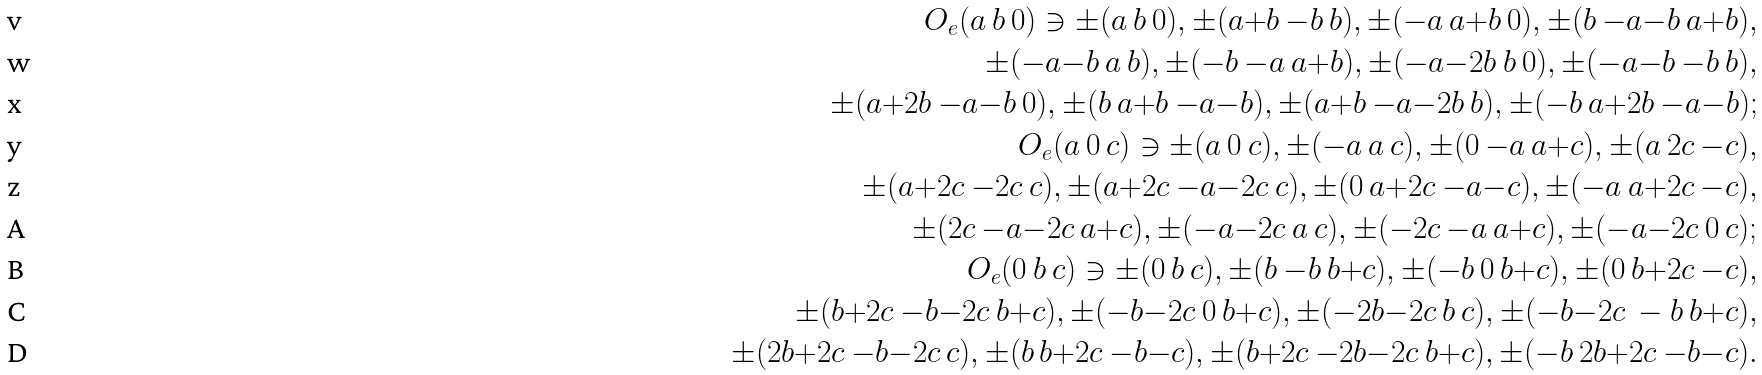Convert formula to latex. <formula><loc_0><loc_0><loc_500><loc_500>O _ { e } ( a \ b \ 0 ) \ni \pm ( a \ b \ 0 ) , \pm ( a { + } b \ { - } b \ b ) , \pm ( { - } a \ a { + } b \ 0 ) , \pm ( b \ { - } a { - } b \ a { + } b ) , \\ \quad \pm ( { - } a { - } b \ a \ b ) , \pm ( { - } b \ { - } a \ a { + } b ) , \pm ( { - } a { - } 2 b \ b \ 0 ) , \pm ( { - } a { - } b \ { - } b \ b ) , \\ \quad \pm ( a { + } 2 b \ { - } a { - } b \ 0 ) , \pm ( b \ a { + } b \ { - } a { - } b ) , \pm ( a { + } b \ { - } a { - } 2 b \ b ) , \pm ( { - } b \ a { + } 2 b \ { - } a { - } b ) ; \\ O _ { e } ( a \ 0 \ c ) \ni \pm ( a \ 0 \ c ) , \pm ( { - } a \ a \ c ) , \pm ( 0 \ { - } a \ a { + } c ) , \pm ( a \ 2 c \ { - } c ) , \\ \quad \pm ( a { + } 2 c \ { - } 2 c \ c ) , \pm ( a { + } 2 c \ { - } a { - } 2 c \ c ) , \pm ( 0 \ a { + } 2 c \ { - } a { - } c ) , \pm ( { - } a \ a { + } 2 c \ { - } c ) , \\ \quad \pm ( 2 c \ { - } a { - } 2 c \ a { + } c ) , \pm ( { - } a { - } 2 c \ a \ c ) , \pm ( { - } 2 c \ { - } a \ a { + } c ) , \pm ( { - } a { - } 2 c \ 0 \ c ) ; \\ O _ { e } ( 0 \ b \ c ) \ni \pm ( 0 \ b \ c ) , \pm ( b \ { - } b \ b { + } c ) , \pm ( { - } b \ 0 \ b { + } c ) , \pm ( 0 \ b { + } 2 c \ { - } c ) , \\ \quad \pm ( b { + } 2 c \ { - } b { - } 2 c \ b { + } c ) , \pm ( { - } b { - } 2 c \ 0 \ b { + } c ) , \pm ( { - } 2 b { - } 2 c \ b \ c ) , \pm ( { - } b { - } 2 c \ - b \ b { + } c ) , \\ \quad \pm ( 2 b { + } 2 c \ { - } b { - } 2 c \ c ) , \pm ( b \ b { + } 2 c \ { - } b { - } c ) , \pm ( b { + } 2 c \ { - } 2 b { - } 2 c \ b { + } c ) , \pm ( { - } b \ 2 b { + } 2 c \ { - } b { - } c ) .</formula> 